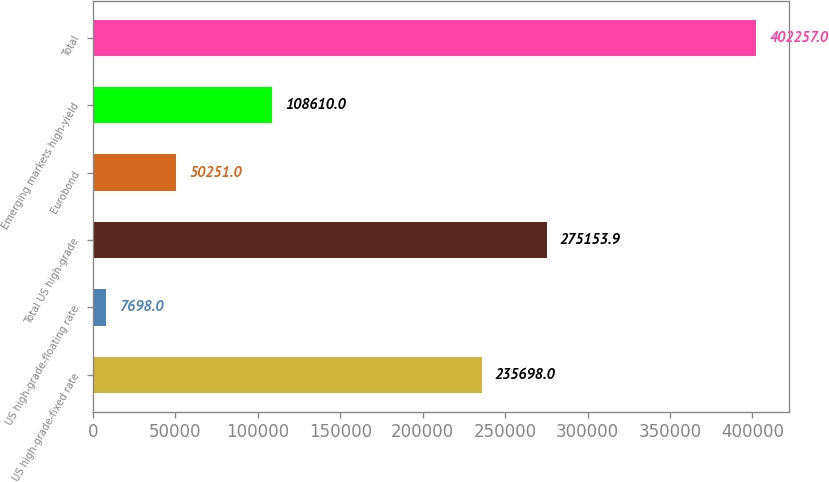<chart> <loc_0><loc_0><loc_500><loc_500><bar_chart><fcel>US high-grade-fixed rate<fcel>US high-grade-floating rate<fcel>Total US high-grade<fcel>Eurobond<fcel>Emerging markets high-yield<fcel>Total<nl><fcel>235698<fcel>7698<fcel>275154<fcel>50251<fcel>108610<fcel>402257<nl></chart> 